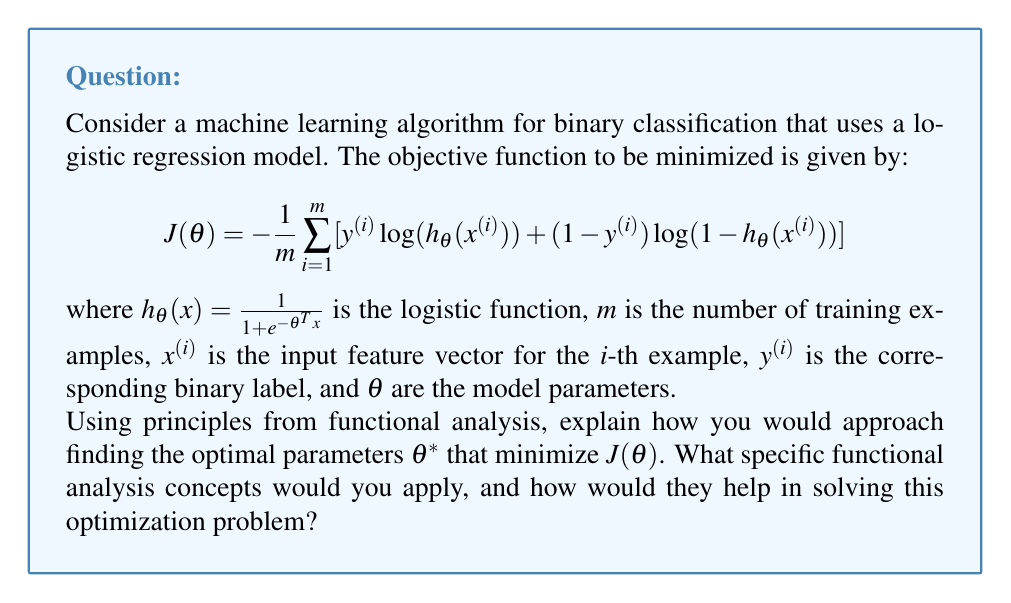Teach me how to tackle this problem. To approach this optimization problem using functional analysis, we can follow these steps:

1. Recognize the problem as a variational problem:
   The objective function $J(\theta)$ can be viewed as a functional, mapping from the space of parameter vectors $\theta$ to real numbers. This allows us to apply techniques from functional analysis.

2. Examine the function space:
   The parameter space for $\theta$ is typically a finite-dimensional vector space, but we can consider it as a subset of an infinite-dimensional Hilbert space for generalization.

3. Apply the Fréchet derivative:
   The Fréchet derivative is a generalization of the gradient to infinite-dimensional spaces. For our finite-dimensional case, it coincides with the regular gradient. We compute:

   $$\nabla J(\theta) = -\frac{1}{m} \sum_{i=1}^m (y^{(i)} - h_\theta(x^{(i)})) x^{(i)}$$

4. Use the principle of steepest descent:
   In functional analysis, the negative gradient gives the direction of steepest descent in the function space. This principle justifies the use of gradient descent algorithms.

5. Apply fixed-point theory:
   The optimal solution $\theta^*$ can be characterized as a fixed point of the operator $T(\theta) = \theta - \alpha \nabla J(\theta)$, where $\alpha$ is the learning rate. This connects our problem to fixed-point theorems in functional analysis.

6. Analyze convergence using Banach fixed-point theorem:
   If $T$ is a contraction mapping (which can be ensured by choosing a small enough $\alpha$), the Banach fixed-point theorem guarantees the convergence of the iteration $\theta_{k+1} = T(\theta_k)$ to the unique fixed point $\theta^*$.

7. Utilize spectral theory:
   The convergence rate of gradient descent can be analyzed using the spectral properties of the Hessian matrix of $J(\theta)$. The eigenvalues of the Hessian determine the local geometry of the function space around the optimum.

8. Apply convex analysis:
   If $J(\theta)$ is convex (which it is for logistic regression), we can use results from convex functional analysis to guarantee the existence and uniqueness of the global minimum.

By applying these functional analysis concepts, we transform the original optimization problem into a well-structured mathematical framework. This allows us to leverage powerful theoretical results to design and analyze efficient algorithms for finding the optimal parameters $\theta^*$.
Answer: The optimal parameters $\theta^*$ can be found by iteratively applying the gradient descent update:

$$\theta_{k+1} = \theta_k - \alpha \nabla J(\theta_k)$$

where $\alpha$ is a suitably chosen learning rate. This process is guaranteed to converge to the global minimum $\theta^*$ due to the convexity of $J(\theta)$ and the principles of functional analysis discussed in the explanation, particularly the Banach fixed-point theorem and convex analysis results. 